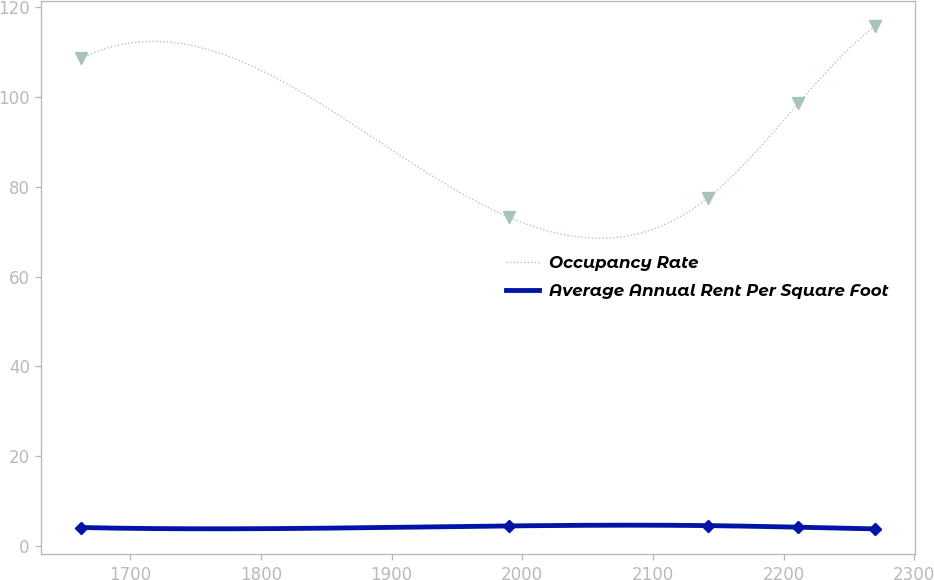<chart> <loc_0><loc_0><loc_500><loc_500><line_chart><ecel><fcel>Occupancy Rate<fcel>Average Annual Rent Per Square Foot<nl><fcel>1662.54<fcel>108.49<fcel>4.21<nl><fcel>1989.86<fcel>73.19<fcel>4.56<nl><fcel>2141.98<fcel>77.44<fcel>4.63<nl><fcel>2211.2<fcel>98.47<fcel>4.28<nl><fcel>2270.26<fcel>115.68<fcel>3.9<nl></chart> 